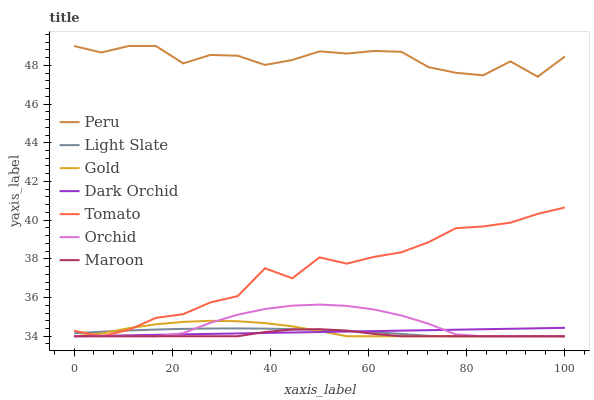Does Maroon have the minimum area under the curve?
Answer yes or no. Yes. Does Peru have the maximum area under the curve?
Answer yes or no. Yes. Does Gold have the minimum area under the curve?
Answer yes or no. No. Does Gold have the maximum area under the curve?
Answer yes or no. No. Is Dark Orchid the smoothest?
Answer yes or no. Yes. Is Peru the roughest?
Answer yes or no. Yes. Is Gold the smoothest?
Answer yes or no. No. Is Gold the roughest?
Answer yes or no. No. Does Tomato have the lowest value?
Answer yes or no. Yes. Does Peru have the lowest value?
Answer yes or no. No. Does Peru have the highest value?
Answer yes or no. Yes. Does Gold have the highest value?
Answer yes or no. No. Is Light Slate less than Peru?
Answer yes or no. Yes. Is Peru greater than Orchid?
Answer yes or no. Yes. Does Gold intersect Tomato?
Answer yes or no. Yes. Is Gold less than Tomato?
Answer yes or no. No. Is Gold greater than Tomato?
Answer yes or no. No. Does Light Slate intersect Peru?
Answer yes or no. No. 